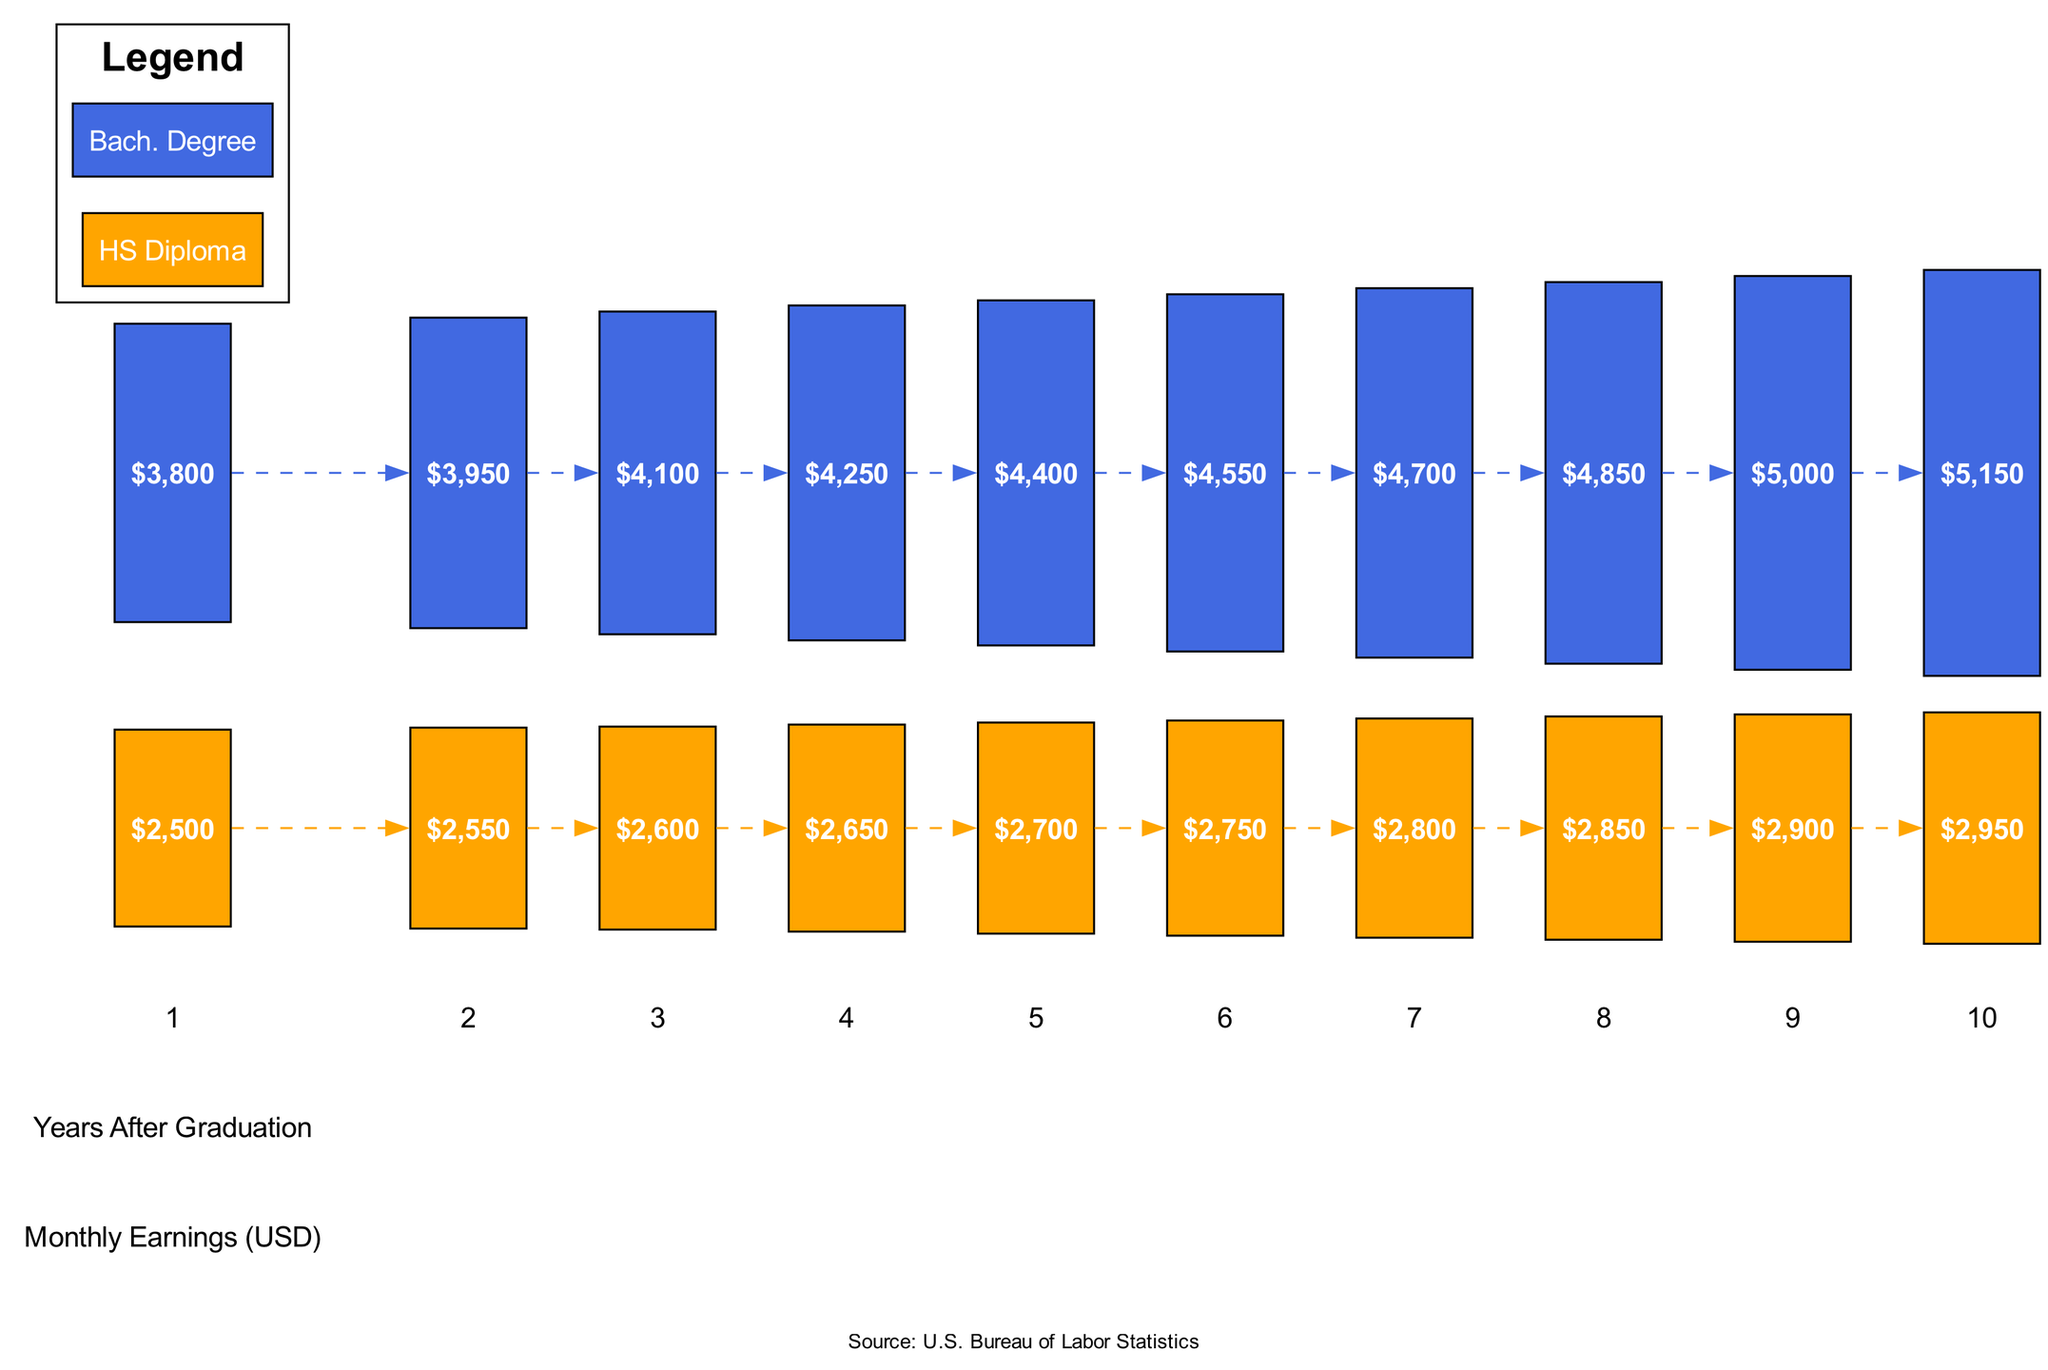What are the monthly earnings for a high school diploma after 5 years? The diagram shows that after 5 years, the monthly earnings for a high school diploma reach 2700 USD.
Answer: 2700 USD What is the highest monthly earning shown for a bachelor's degree? The diagram indicates that the highest monthly earning for a bachelor's degree after 10 years is 5150 USD.
Answer: 5150 USD How many years does it take for the monthly earnings of a bachelor's degree to reach 5000 USD? According to the data, the monthly earnings for a bachelor's degree reach 5000 USD at year 9 after graduation.
Answer: 9 years What is the difference in monthly earnings between a high school diploma and a bachelor's degree in the first year? In the first year, the earnings for a high school diploma are 2500 USD and for a bachelor's degree are 3800 USD, creating a difference of 1300 USD.
Answer: 1300 USD Which trend line has a steeper growth over the 10-year period? Analyzing the trend lines, the bachelor's degree shows a more considerable and consistent increase over the years, indicating that it has a steeper growth compared to the high school diploma.
Answer: Bachelor's Degree Trend Line In what year do the monthly earnings of a high school diploma surpass 3000 USD? The data reveals that monthly earnings for a high school diploma do not reach 3000 USD during the 10-year period, as the maximum is 2950 USD in year 10.
Answer: N/A What is the average monthly earning for a bachelor's degree after 10 years? The average monthly earning for a bachelor's degree is 5150 USD after 10 years as shown in the final data point for that education level.
Answer: 5150 USD Which education level has higher earnings after 6 years? The diagram illustrates that after 6 years, the monthly earnings for a bachelor's degree (4550 USD) are higher than those for a high school diploma (2750 USD).
Answer: Bachelor's Degree At which year do both education levels show an increase in earnings? Both education levels show an increase in earnings every year, from year 1 through year 10 as indicated by the ascending values in both series.
Answer: Every year 